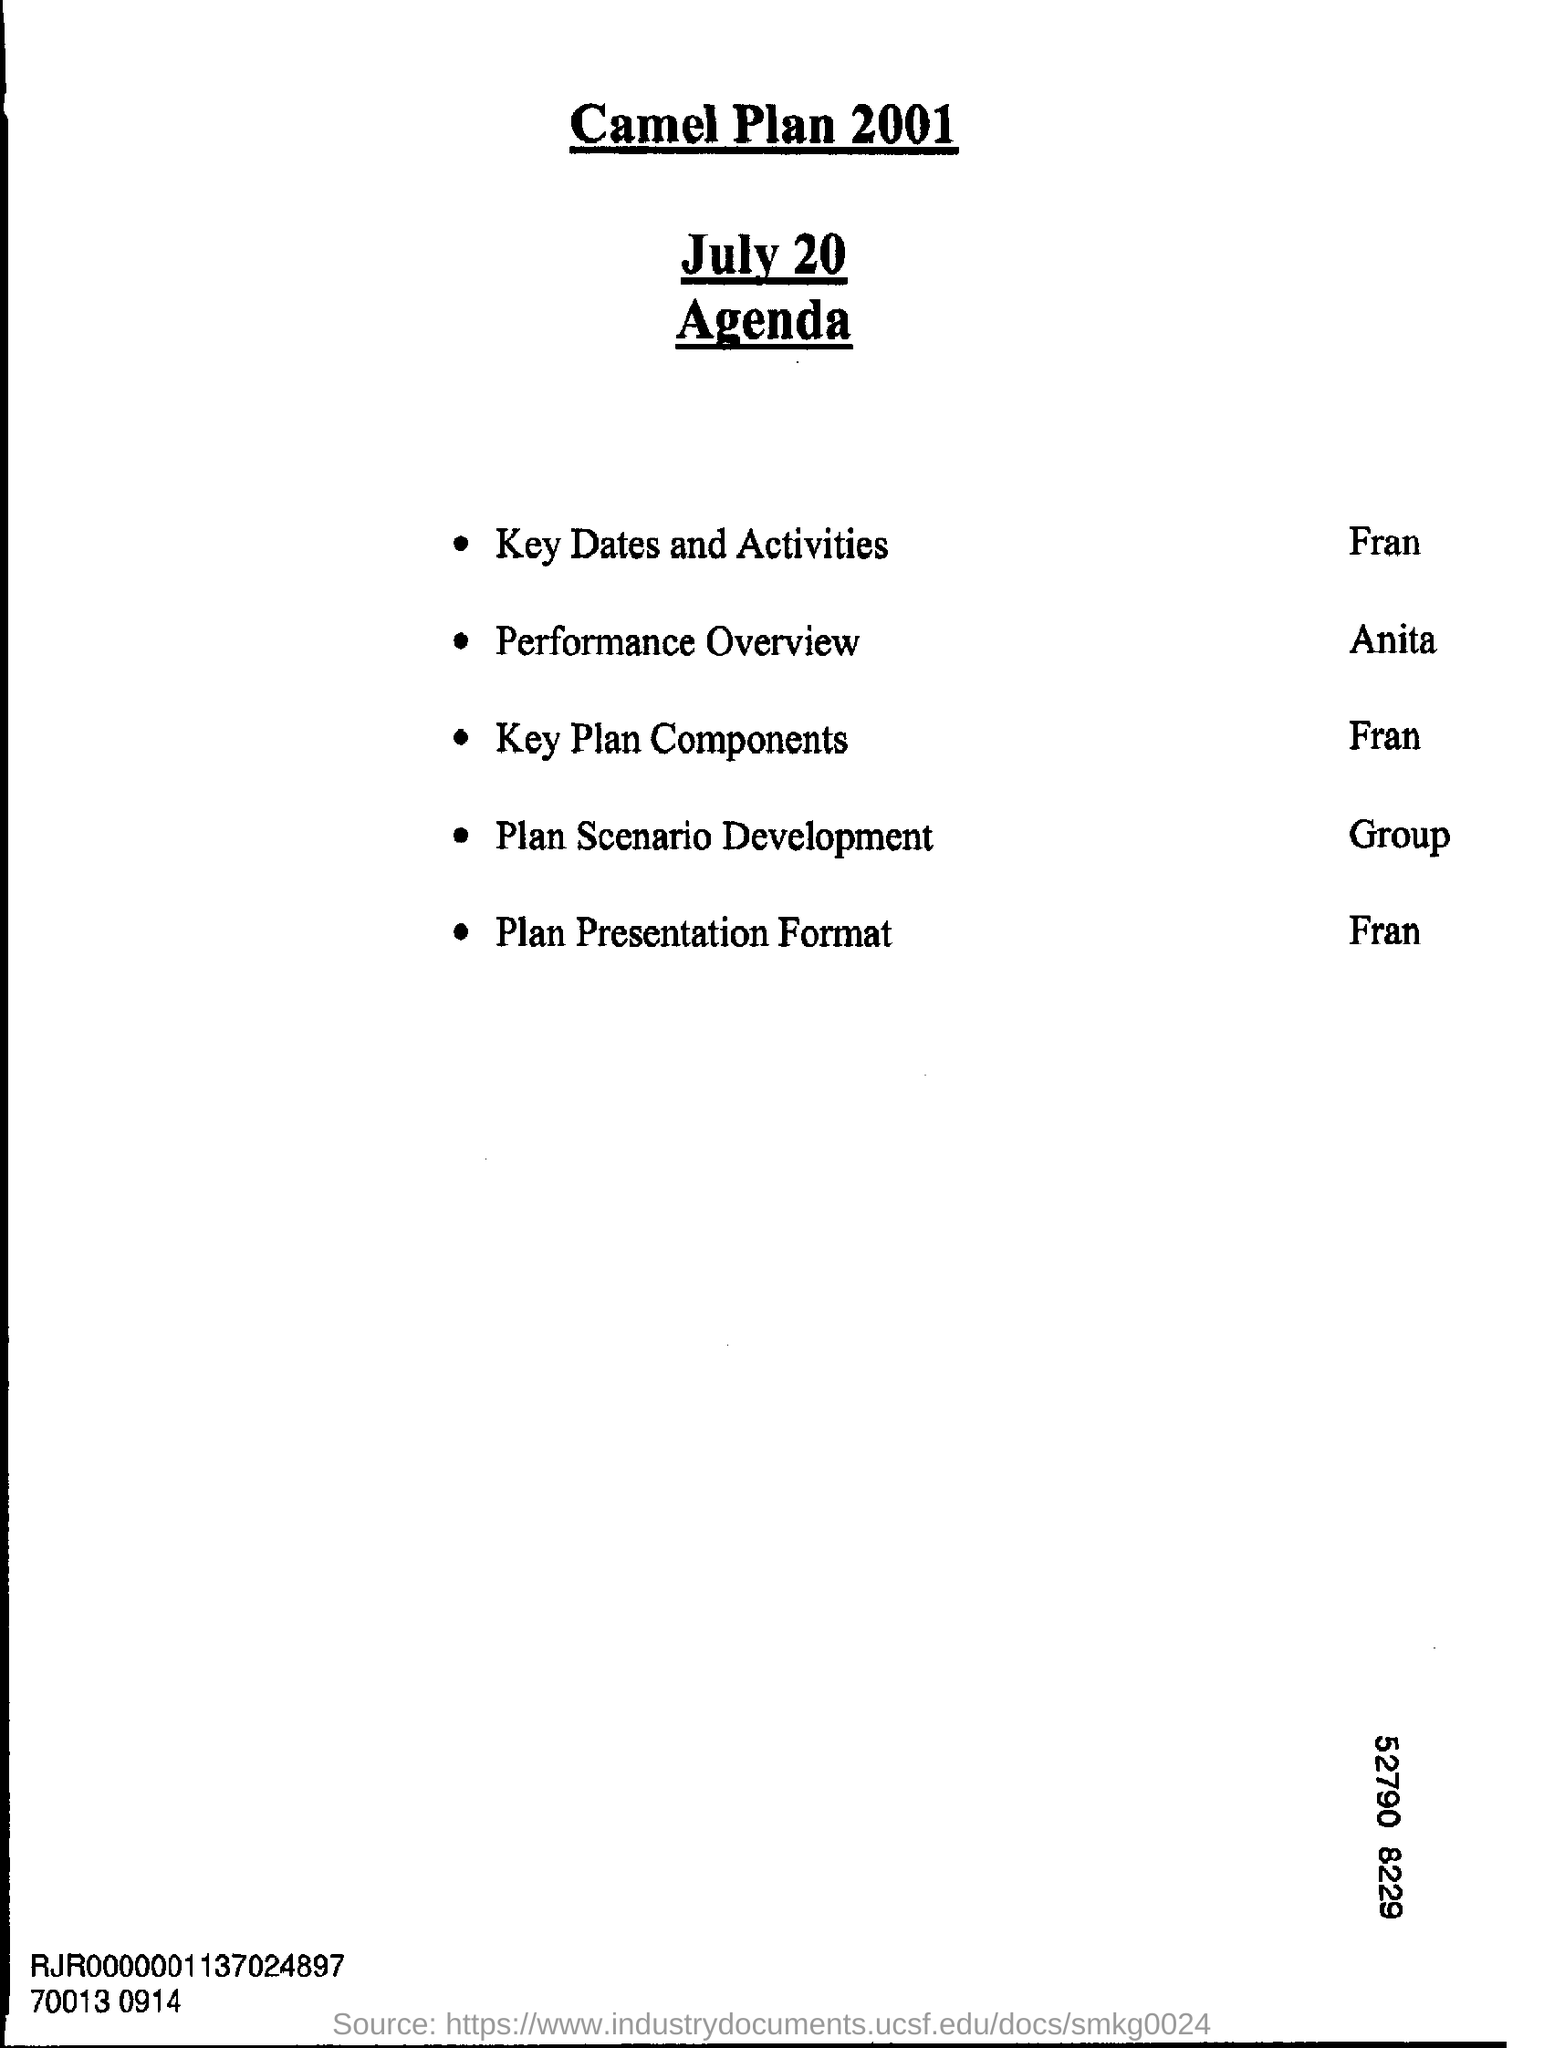What is the title of the Agenda?
Offer a very short reply. Camel Plan 2001. 